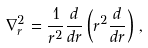Convert formula to latex. <formula><loc_0><loc_0><loc_500><loc_500>\nabla _ { r } ^ { 2 } = \frac { 1 } { r ^ { 2 } } \frac { d } { d r } \left ( r ^ { 2 } \frac { d } { d r } \right ) \, ,</formula> 